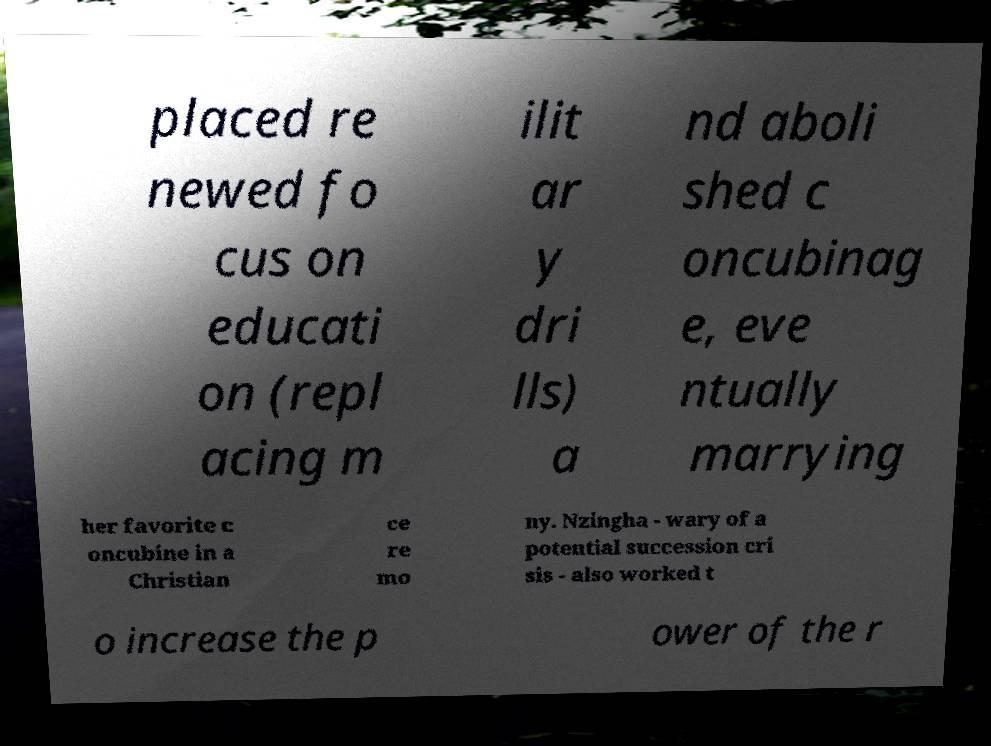Please read and relay the text visible in this image. What does it say? placed re newed fo cus on educati on (repl acing m ilit ar y dri lls) a nd aboli shed c oncubinag e, eve ntually marrying her favorite c oncubine in a Christian ce re mo ny. Nzingha - wary of a potential succession cri sis - also worked t o increase the p ower of the r 